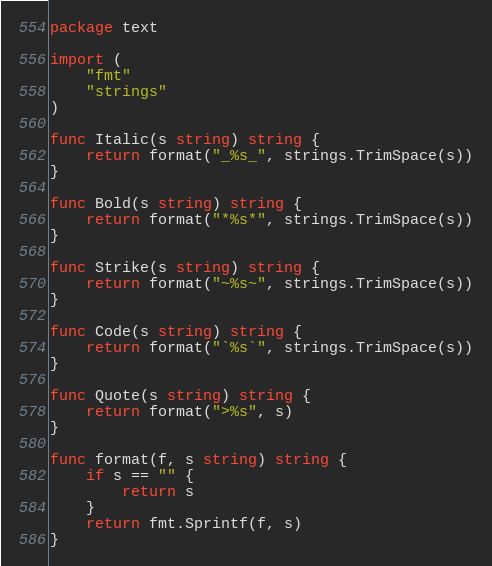Convert code to text. <code><loc_0><loc_0><loc_500><loc_500><_Go_>package text

import (
	"fmt"
	"strings"
)

func Italic(s string) string {
	return format("_%s_", strings.TrimSpace(s))
}

func Bold(s string) string {
	return format("*%s*", strings.TrimSpace(s))
}

func Strike(s string) string {
	return format("~%s~", strings.TrimSpace(s))
}

func Code(s string) string {
	return format("`%s`", strings.TrimSpace(s))
}

func Quote(s string) string {
	return format(">%s", s)
}

func format(f, s string) string {
	if s == "" {
		return s
	}
	return fmt.Sprintf(f, s)
}
</code> 